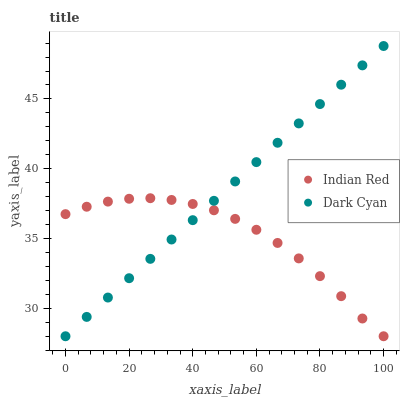Does Indian Red have the minimum area under the curve?
Answer yes or no. Yes. Does Dark Cyan have the maximum area under the curve?
Answer yes or no. Yes. Does Indian Red have the maximum area under the curve?
Answer yes or no. No. Is Dark Cyan the smoothest?
Answer yes or no. Yes. Is Indian Red the roughest?
Answer yes or no. Yes. Is Indian Red the smoothest?
Answer yes or no. No. Does Dark Cyan have the lowest value?
Answer yes or no. Yes. Does Dark Cyan have the highest value?
Answer yes or no. Yes. Does Indian Red have the highest value?
Answer yes or no. No. Does Dark Cyan intersect Indian Red?
Answer yes or no. Yes. Is Dark Cyan less than Indian Red?
Answer yes or no. No. Is Dark Cyan greater than Indian Red?
Answer yes or no. No. 